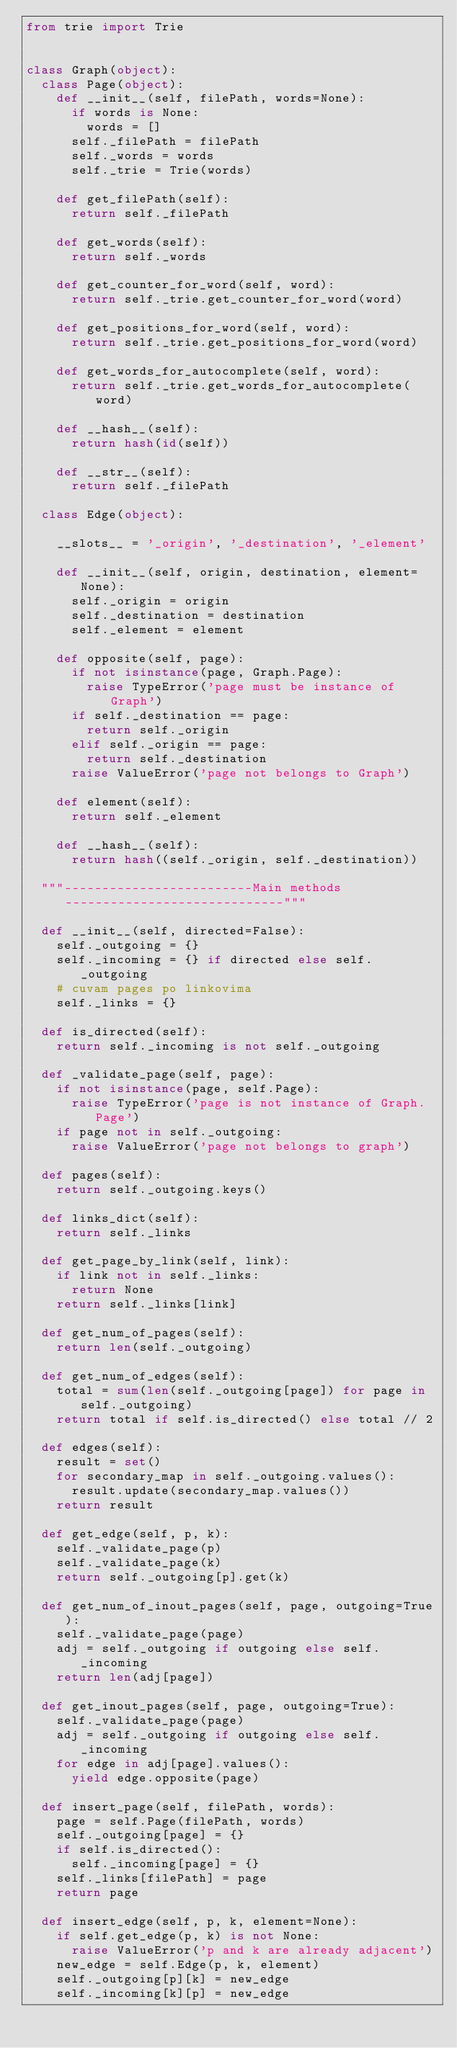Convert code to text. <code><loc_0><loc_0><loc_500><loc_500><_Python_>from trie import Trie


class Graph(object):
	class Page(object):
		def __init__(self, filePath, words=None):
			if words is None:
				words = []
			self._filePath = filePath
			self._words = words
			self._trie = Trie(words)

		def get_filePath(self):
			return self._filePath

		def get_words(self):
			return self._words

		def get_counter_for_word(self, word):
			return self._trie.get_counter_for_word(word)

		def get_positions_for_word(self, word):
			return self._trie.get_positions_for_word(word)

		def get_words_for_autocomplete(self, word):
			return self._trie.get_words_for_autocomplete(word)

		def __hash__(self):
			return hash(id(self))

		def __str__(self):
			return self._filePath

	class Edge(object):

		__slots__ = '_origin', '_destination', '_element'

		def __init__(self, origin, destination, element=None):
			self._origin = origin
			self._destination = destination
			self._element = element

		def opposite(self, page):
			if not isinstance(page, Graph.Page):
				raise TypeError('page must be instance of Graph')
			if self._destination == page:
				return self._origin
			elif self._origin == page:
				return self._destination
			raise ValueError('page not belongs to Graph')

		def element(self):
			return self._element

		def __hash__(self):
			return hash((self._origin, self._destination))

	"""-------------------------Main methods-----------------------------"""

	def __init__(self, directed=False):
		self._outgoing = {}
		self._incoming = {} if directed else self._outgoing
		# cuvam pages po linkovima
		self._links = {}

	def is_directed(self):
		return self._incoming is not self._outgoing

	def _validate_page(self, page):
		if not isinstance(page, self.Page):
			raise TypeError('page is not instance of Graph.Page')
		if page not in self._outgoing:
			raise ValueError('page not belongs to graph')

	def pages(self):
		return self._outgoing.keys()

	def links_dict(self):
		return self._links

	def get_page_by_link(self, link):
		if link not in self._links:
			return None
		return self._links[link]

	def get_num_of_pages(self):
		return len(self._outgoing)

	def get_num_of_edges(self):
		total = sum(len(self._outgoing[page]) for page in self._outgoing)
		return total if self.is_directed() else total // 2

	def edges(self):
		result = set()
		for secondary_map in self._outgoing.values():
			result.update(secondary_map.values())
		return result

	def get_edge(self, p, k):
		self._validate_page(p)
		self._validate_page(k)
		return self._outgoing[p].get(k)

	def get_num_of_inout_pages(self, page, outgoing=True):
		self._validate_page(page)
		adj = self._outgoing if outgoing else self._incoming
		return len(adj[page])

	def get_inout_pages(self, page, outgoing=True):
		self._validate_page(page)
		adj = self._outgoing if outgoing else self._incoming
		for edge in adj[page].values():
			yield edge.opposite(page)

	def insert_page(self, filePath, words):
		page = self.Page(filePath, words)
		self._outgoing[page] = {}
		if self.is_directed():
			self._incoming[page] = {}
		self._links[filePath] = page
		return page

	def insert_edge(self, p, k, element=None):
		if self.get_edge(p, k) is not None:
			raise ValueError('p and k are already adjacent')
		new_edge = self.Edge(p, k, element)
		self._outgoing[p][k] = new_edge
		self._incoming[k][p] = new_edge
</code> 